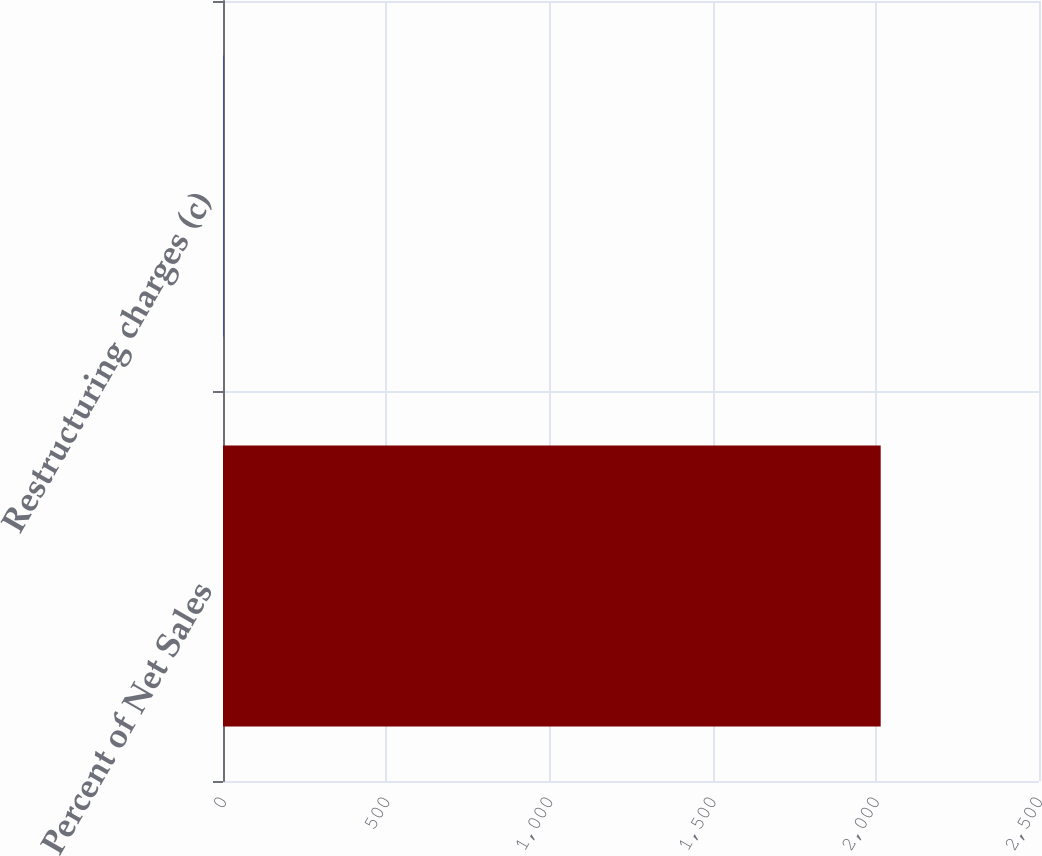<chart> <loc_0><loc_0><loc_500><loc_500><bar_chart><fcel>Percent of Net Sales<fcel>Restructuring charges (c)<nl><fcel>2015<fcel>1.7<nl></chart> 